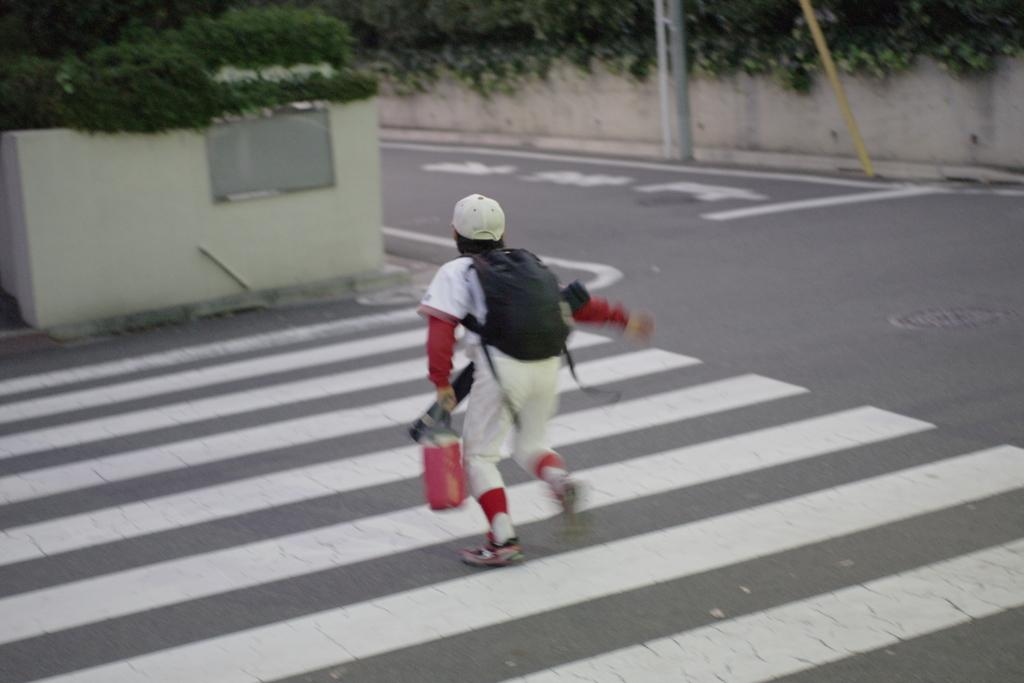What is the main subject of the picture? The main subject of the picture is a kid. What is the kid doing in the image? The kid is running on the road. What can be seen in the background of the image? There are plants, a wall, a road, and poles in the background of the image. What type of chair can be seen in the image? There is no chair present in the image. Can you tell me how many stones are visible in the image? There are no stones visible in the image. 